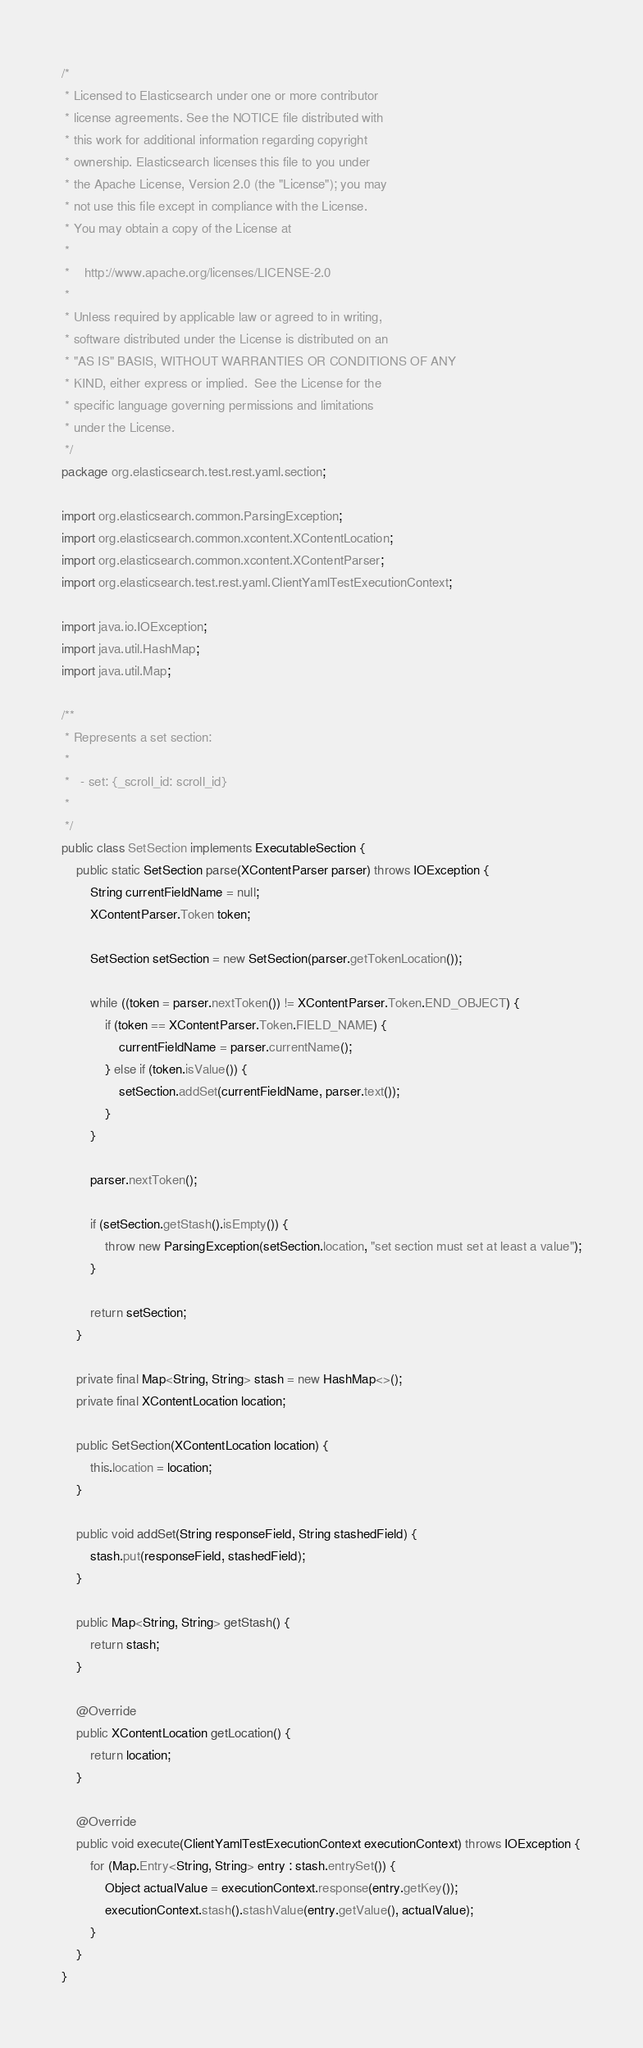<code> <loc_0><loc_0><loc_500><loc_500><_Java_>/*
 * Licensed to Elasticsearch under one or more contributor
 * license agreements. See the NOTICE file distributed with
 * this work for additional information regarding copyright
 * ownership. Elasticsearch licenses this file to you under
 * the Apache License, Version 2.0 (the "License"); you may
 * not use this file except in compliance with the License.
 * You may obtain a copy of the License at
 *
 *    http://www.apache.org/licenses/LICENSE-2.0
 *
 * Unless required by applicable law or agreed to in writing,
 * software distributed under the License is distributed on an
 * "AS IS" BASIS, WITHOUT WARRANTIES OR CONDITIONS OF ANY
 * KIND, either express or implied.  See the License for the
 * specific language governing permissions and limitations
 * under the License.
 */
package org.elasticsearch.test.rest.yaml.section;

import org.elasticsearch.common.ParsingException;
import org.elasticsearch.common.xcontent.XContentLocation;
import org.elasticsearch.common.xcontent.XContentParser;
import org.elasticsearch.test.rest.yaml.ClientYamlTestExecutionContext;

import java.io.IOException;
import java.util.HashMap;
import java.util.Map;

/**
 * Represents a set section:
 *
 *   - set: {_scroll_id: scroll_id}
 *
 */
public class SetSection implements ExecutableSection {
    public static SetSection parse(XContentParser parser) throws IOException {
        String currentFieldName = null;
        XContentParser.Token token;

        SetSection setSection = new SetSection(parser.getTokenLocation());

        while ((token = parser.nextToken()) != XContentParser.Token.END_OBJECT) {
            if (token == XContentParser.Token.FIELD_NAME) {
                currentFieldName = parser.currentName();
            } else if (token.isValue()) {
                setSection.addSet(currentFieldName, parser.text());
            }
        }

        parser.nextToken();

        if (setSection.getStash().isEmpty()) {
            throw new ParsingException(setSection.location, "set section must set at least a value");
        }

        return setSection;
    }

    private final Map<String, String> stash = new HashMap<>();
    private final XContentLocation location;

    public SetSection(XContentLocation location) {
        this.location = location;
    }

    public void addSet(String responseField, String stashedField) {
        stash.put(responseField, stashedField);
    }

    public Map<String, String> getStash() {
        return stash;
    }

    @Override
    public XContentLocation getLocation() {
        return location;
    }

    @Override
    public void execute(ClientYamlTestExecutionContext executionContext) throws IOException {
        for (Map.Entry<String, String> entry : stash.entrySet()) {
            Object actualValue = executionContext.response(entry.getKey());
            executionContext.stash().stashValue(entry.getValue(), actualValue);
        }
    }
}
</code> 